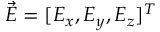<formula> <loc_0><loc_0><loc_500><loc_500>\vec { E } = [ E _ { x } , E _ { y } , E _ { z } ] ^ { T }</formula> 